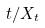Convert formula to latex. <formula><loc_0><loc_0><loc_500><loc_500>t / X _ { t }</formula> 